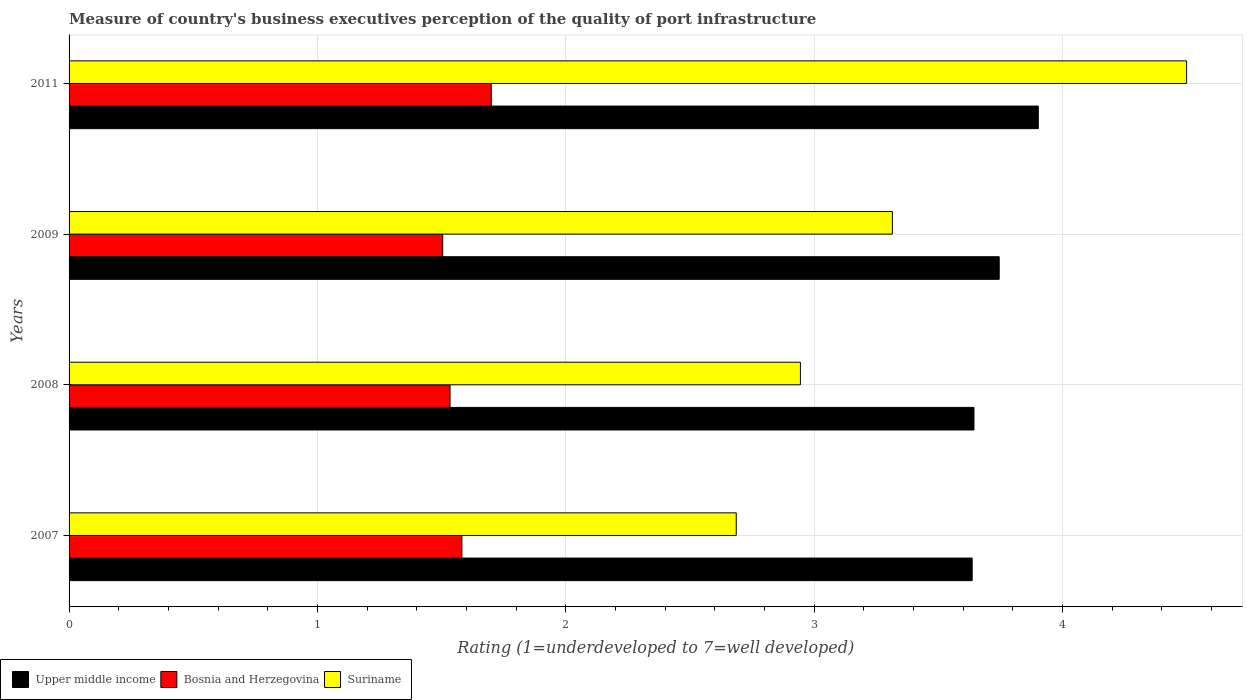What is the ratings of the quality of port infrastructure in Upper middle income in 2007?
Provide a succinct answer. 3.64. Across all years, what is the maximum ratings of the quality of port infrastructure in Upper middle income?
Provide a short and direct response. 3.9. Across all years, what is the minimum ratings of the quality of port infrastructure in Suriname?
Keep it short and to the point. 2.69. In which year was the ratings of the quality of port infrastructure in Upper middle income maximum?
Give a very brief answer. 2011. What is the total ratings of the quality of port infrastructure in Suriname in the graph?
Provide a succinct answer. 13.45. What is the difference between the ratings of the quality of port infrastructure in Suriname in 2007 and that in 2009?
Provide a succinct answer. -0.63. What is the difference between the ratings of the quality of port infrastructure in Bosnia and Herzegovina in 2008 and the ratings of the quality of port infrastructure in Upper middle income in 2007?
Keep it short and to the point. -2.1. What is the average ratings of the quality of port infrastructure in Bosnia and Herzegovina per year?
Offer a very short reply. 1.58. In the year 2007, what is the difference between the ratings of the quality of port infrastructure in Upper middle income and ratings of the quality of port infrastructure in Bosnia and Herzegovina?
Your answer should be compact. 2.05. In how many years, is the ratings of the quality of port infrastructure in Suriname greater than 1.8 ?
Ensure brevity in your answer.  4. What is the ratio of the ratings of the quality of port infrastructure in Bosnia and Herzegovina in 2007 to that in 2009?
Ensure brevity in your answer.  1.05. Is the ratings of the quality of port infrastructure in Upper middle income in 2009 less than that in 2011?
Provide a succinct answer. Yes. Is the difference between the ratings of the quality of port infrastructure in Upper middle income in 2009 and 2011 greater than the difference between the ratings of the quality of port infrastructure in Bosnia and Herzegovina in 2009 and 2011?
Make the answer very short. Yes. What is the difference between the highest and the second highest ratings of the quality of port infrastructure in Upper middle income?
Provide a short and direct response. 0.16. What is the difference between the highest and the lowest ratings of the quality of port infrastructure in Suriname?
Offer a very short reply. 1.81. In how many years, is the ratings of the quality of port infrastructure in Suriname greater than the average ratings of the quality of port infrastructure in Suriname taken over all years?
Offer a very short reply. 1. Is the sum of the ratings of the quality of port infrastructure in Upper middle income in 2008 and 2009 greater than the maximum ratings of the quality of port infrastructure in Bosnia and Herzegovina across all years?
Make the answer very short. Yes. What does the 1st bar from the top in 2009 represents?
Offer a very short reply. Suriname. What does the 1st bar from the bottom in 2009 represents?
Ensure brevity in your answer.  Upper middle income. How many bars are there?
Offer a very short reply. 12. How many years are there in the graph?
Provide a succinct answer. 4. What is the difference between two consecutive major ticks on the X-axis?
Provide a succinct answer. 1. Where does the legend appear in the graph?
Provide a short and direct response. Bottom left. How are the legend labels stacked?
Give a very brief answer. Horizontal. What is the title of the graph?
Offer a terse response. Measure of country's business executives perception of the quality of port infrastructure. What is the label or title of the X-axis?
Provide a succinct answer. Rating (1=underdeveloped to 7=well developed). What is the Rating (1=underdeveloped to 7=well developed) of Upper middle income in 2007?
Your answer should be very brief. 3.64. What is the Rating (1=underdeveloped to 7=well developed) of Bosnia and Herzegovina in 2007?
Provide a short and direct response. 1.58. What is the Rating (1=underdeveloped to 7=well developed) of Suriname in 2007?
Your answer should be compact. 2.69. What is the Rating (1=underdeveloped to 7=well developed) of Upper middle income in 2008?
Your answer should be compact. 3.64. What is the Rating (1=underdeveloped to 7=well developed) in Bosnia and Herzegovina in 2008?
Your answer should be very brief. 1.53. What is the Rating (1=underdeveloped to 7=well developed) of Suriname in 2008?
Your response must be concise. 2.94. What is the Rating (1=underdeveloped to 7=well developed) in Upper middle income in 2009?
Offer a very short reply. 3.75. What is the Rating (1=underdeveloped to 7=well developed) in Bosnia and Herzegovina in 2009?
Your response must be concise. 1.5. What is the Rating (1=underdeveloped to 7=well developed) of Suriname in 2009?
Offer a terse response. 3.32. What is the Rating (1=underdeveloped to 7=well developed) of Upper middle income in 2011?
Offer a terse response. 3.9. Across all years, what is the maximum Rating (1=underdeveloped to 7=well developed) in Upper middle income?
Your answer should be very brief. 3.9. Across all years, what is the minimum Rating (1=underdeveloped to 7=well developed) of Upper middle income?
Provide a succinct answer. 3.64. Across all years, what is the minimum Rating (1=underdeveloped to 7=well developed) in Bosnia and Herzegovina?
Offer a very short reply. 1.5. Across all years, what is the minimum Rating (1=underdeveloped to 7=well developed) of Suriname?
Keep it short and to the point. 2.69. What is the total Rating (1=underdeveloped to 7=well developed) of Upper middle income in the graph?
Ensure brevity in your answer.  14.93. What is the total Rating (1=underdeveloped to 7=well developed) of Bosnia and Herzegovina in the graph?
Make the answer very short. 6.32. What is the total Rating (1=underdeveloped to 7=well developed) of Suriname in the graph?
Your response must be concise. 13.45. What is the difference between the Rating (1=underdeveloped to 7=well developed) of Upper middle income in 2007 and that in 2008?
Offer a very short reply. -0.01. What is the difference between the Rating (1=underdeveloped to 7=well developed) in Bosnia and Herzegovina in 2007 and that in 2008?
Offer a very short reply. 0.05. What is the difference between the Rating (1=underdeveloped to 7=well developed) in Suriname in 2007 and that in 2008?
Provide a short and direct response. -0.26. What is the difference between the Rating (1=underdeveloped to 7=well developed) of Upper middle income in 2007 and that in 2009?
Your answer should be very brief. -0.11. What is the difference between the Rating (1=underdeveloped to 7=well developed) of Bosnia and Herzegovina in 2007 and that in 2009?
Your answer should be compact. 0.08. What is the difference between the Rating (1=underdeveloped to 7=well developed) in Suriname in 2007 and that in 2009?
Your answer should be very brief. -0.63. What is the difference between the Rating (1=underdeveloped to 7=well developed) in Upper middle income in 2007 and that in 2011?
Your answer should be compact. -0.27. What is the difference between the Rating (1=underdeveloped to 7=well developed) of Bosnia and Herzegovina in 2007 and that in 2011?
Give a very brief answer. -0.12. What is the difference between the Rating (1=underdeveloped to 7=well developed) in Suriname in 2007 and that in 2011?
Your answer should be compact. -1.81. What is the difference between the Rating (1=underdeveloped to 7=well developed) of Upper middle income in 2008 and that in 2009?
Your answer should be compact. -0.1. What is the difference between the Rating (1=underdeveloped to 7=well developed) in Bosnia and Herzegovina in 2008 and that in 2009?
Your response must be concise. 0.03. What is the difference between the Rating (1=underdeveloped to 7=well developed) of Suriname in 2008 and that in 2009?
Offer a terse response. -0.37. What is the difference between the Rating (1=underdeveloped to 7=well developed) in Upper middle income in 2008 and that in 2011?
Provide a short and direct response. -0.26. What is the difference between the Rating (1=underdeveloped to 7=well developed) of Bosnia and Herzegovina in 2008 and that in 2011?
Provide a succinct answer. -0.17. What is the difference between the Rating (1=underdeveloped to 7=well developed) in Suriname in 2008 and that in 2011?
Keep it short and to the point. -1.55. What is the difference between the Rating (1=underdeveloped to 7=well developed) of Upper middle income in 2009 and that in 2011?
Your answer should be very brief. -0.16. What is the difference between the Rating (1=underdeveloped to 7=well developed) of Bosnia and Herzegovina in 2009 and that in 2011?
Give a very brief answer. -0.2. What is the difference between the Rating (1=underdeveloped to 7=well developed) of Suriname in 2009 and that in 2011?
Offer a very short reply. -1.18. What is the difference between the Rating (1=underdeveloped to 7=well developed) in Upper middle income in 2007 and the Rating (1=underdeveloped to 7=well developed) in Bosnia and Herzegovina in 2008?
Your answer should be very brief. 2.1. What is the difference between the Rating (1=underdeveloped to 7=well developed) of Upper middle income in 2007 and the Rating (1=underdeveloped to 7=well developed) of Suriname in 2008?
Your response must be concise. 0.69. What is the difference between the Rating (1=underdeveloped to 7=well developed) in Bosnia and Herzegovina in 2007 and the Rating (1=underdeveloped to 7=well developed) in Suriname in 2008?
Make the answer very short. -1.36. What is the difference between the Rating (1=underdeveloped to 7=well developed) in Upper middle income in 2007 and the Rating (1=underdeveloped to 7=well developed) in Bosnia and Herzegovina in 2009?
Give a very brief answer. 2.13. What is the difference between the Rating (1=underdeveloped to 7=well developed) of Upper middle income in 2007 and the Rating (1=underdeveloped to 7=well developed) of Suriname in 2009?
Offer a terse response. 0.32. What is the difference between the Rating (1=underdeveloped to 7=well developed) in Bosnia and Herzegovina in 2007 and the Rating (1=underdeveloped to 7=well developed) in Suriname in 2009?
Your answer should be very brief. -1.73. What is the difference between the Rating (1=underdeveloped to 7=well developed) of Upper middle income in 2007 and the Rating (1=underdeveloped to 7=well developed) of Bosnia and Herzegovina in 2011?
Offer a very short reply. 1.94. What is the difference between the Rating (1=underdeveloped to 7=well developed) in Upper middle income in 2007 and the Rating (1=underdeveloped to 7=well developed) in Suriname in 2011?
Provide a succinct answer. -0.86. What is the difference between the Rating (1=underdeveloped to 7=well developed) of Bosnia and Herzegovina in 2007 and the Rating (1=underdeveloped to 7=well developed) of Suriname in 2011?
Your answer should be very brief. -2.92. What is the difference between the Rating (1=underdeveloped to 7=well developed) of Upper middle income in 2008 and the Rating (1=underdeveloped to 7=well developed) of Bosnia and Herzegovina in 2009?
Offer a very short reply. 2.14. What is the difference between the Rating (1=underdeveloped to 7=well developed) in Upper middle income in 2008 and the Rating (1=underdeveloped to 7=well developed) in Suriname in 2009?
Give a very brief answer. 0.33. What is the difference between the Rating (1=underdeveloped to 7=well developed) in Bosnia and Herzegovina in 2008 and the Rating (1=underdeveloped to 7=well developed) in Suriname in 2009?
Offer a very short reply. -1.78. What is the difference between the Rating (1=underdeveloped to 7=well developed) of Upper middle income in 2008 and the Rating (1=underdeveloped to 7=well developed) of Bosnia and Herzegovina in 2011?
Offer a terse response. 1.94. What is the difference between the Rating (1=underdeveloped to 7=well developed) in Upper middle income in 2008 and the Rating (1=underdeveloped to 7=well developed) in Suriname in 2011?
Keep it short and to the point. -0.86. What is the difference between the Rating (1=underdeveloped to 7=well developed) of Bosnia and Herzegovina in 2008 and the Rating (1=underdeveloped to 7=well developed) of Suriname in 2011?
Make the answer very short. -2.97. What is the difference between the Rating (1=underdeveloped to 7=well developed) of Upper middle income in 2009 and the Rating (1=underdeveloped to 7=well developed) of Bosnia and Herzegovina in 2011?
Ensure brevity in your answer.  2.05. What is the difference between the Rating (1=underdeveloped to 7=well developed) of Upper middle income in 2009 and the Rating (1=underdeveloped to 7=well developed) of Suriname in 2011?
Provide a succinct answer. -0.75. What is the difference between the Rating (1=underdeveloped to 7=well developed) of Bosnia and Herzegovina in 2009 and the Rating (1=underdeveloped to 7=well developed) of Suriname in 2011?
Provide a short and direct response. -3. What is the average Rating (1=underdeveloped to 7=well developed) in Upper middle income per year?
Keep it short and to the point. 3.73. What is the average Rating (1=underdeveloped to 7=well developed) of Bosnia and Herzegovina per year?
Your response must be concise. 1.58. What is the average Rating (1=underdeveloped to 7=well developed) in Suriname per year?
Your answer should be compact. 3.36. In the year 2007, what is the difference between the Rating (1=underdeveloped to 7=well developed) in Upper middle income and Rating (1=underdeveloped to 7=well developed) in Bosnia and Herzegovina?
Keep it short and to the point. 2.05. In the year 2007, what is the difference between the Rating (1=underdeveloped to 7=well developed) of Bosnia and Herzegovina and Rating (1=underdeveloped to 7=well developed) of Suriname?
Provide a short and direct response. -1.1. In the year 2008, what is the difference between the Rating (1=underdeveloped to 7=well developed) of Upper middle income and Rating (1=underdeveloped to 7=well developed) of Bosnia and Herzegovina?
Give a very brief answer. 2.11. In the year 2008, what is the difference between the Rating (1=underdeveloped to 7=well developed) in Upper middle income and Rating (1=underdeveloped to 7=well developed) in Suriname?
Provide a short and direct response. 0.7. In the year 2008, what is the difference between the Rating (1=underdeveloped to 7=well developed) of Bosnia and Herzegovina and Rating (1=underdeveloped to 7=well developed) of Suriname?
Make the answer very short. -1.41. In the year 2009, what is the difference between the Rating (1=underdeveloped to 7=well developed) in Upper middle income and Rating (1=underdeveloped to 7=well developed) in Bosnia and Herzegovina?
Your answer should be very brief. 2.24. In the year 2009, what is the difference between the Rating (1=underdeveloped to 7=well developed) in Upper middle income and Rating (1=underdeveloped to 7=well developed) in Suriname?
Your answer should be compact. 0.43. In the year 2009, what is the difference between the Rating (1=underdeveloped to 7=well developed) in Bosnia and Herzegovina and Rating (1=underdeveloped to 7=well developed) in Suriname?
Give a very brief answer. -1.81. In the year 2011, what is the difference between the Rating (1=underdeveloped to 7=well developed) of Upper middle income and Rating (1=underdeveloped to 7=well developed) of Bosnia and Herzegovina?
Provide a short and direct response. 2.2. In the year 2011, what is the difference between the Rating (1=underdeveloped to 7=well developed) in Upper middle income and Rating (1=underdeveloped to 7=well developed) in Suriname?
Ensure brevity in your answer.  -0.6. What is the ratio of the Rating (1=underdeveloped to 7=well developed) in Upper middle income in 2007 to that in 2008?
Make the answer very short. 1. What is the ratio of the Rating (1=underdeveloped to 7=well developed) in Bosnia and Herzegovina in 2007 to that in 2008?
Give a very brief answer. 1.03. What is the ratio of the Rating (1=underdeveloped to 7=well developed) of Suriname in 2007 to that in 2008?
Keep it short and to the point. 0.91. What is the ratio of the Rating (1=underdeveloped to 7=well developed) in Upper middle income in 2007 to that in 2009?
Make the answer very short. 0.97. What is the ratio of the Rating (1=underdeveloped to 7=well developed) in Bosnia and Herzegovina in 2007 to that in 2009?
Keep it short and to the point. 1.05. What is the ratio of the Rating (1=underdeveloped to 7=well developed) of Suriname in 2007 to that in 2009?
Provide a short and direct response. 0.81. What is the ratio of the Rating (1=underdeveloped to 7=well developed) in Upper middle income in 2007 to that in 2011?
Provide a short and direct response. 0.93. What is the ratio of the Rating (1=underdeveloped to 7=well developed) in Bosnia and Herzegovina in 2007 to that in 2011?
Offer a terse response. 0.93. What is the ratio of the Rating (1=underdeveloped to 7=well developed) in Suriname in 2007 to that in 2011?
Make the answer very short. 0.6. What is the ratio of the Rating (1=underdeveloped to 7=well developed) in Upper middle income in 2008 to that in 2009?
Offer a terse response. 0.97. What is the ratio of the Rating (1=underdeveloped to 7=well developed) of Bosnia and Herzegovina in 2008 to that in 2009?
Provide a succinct answer. 1.02. What is the ratio of the Rating (1=underdeveloped to 7=well developed) of Suriname in 2008 to that in 2009?
Ensure brevity in your answer.  0.89. What is the ratio of the Rating (1=underdeveloped to 7=well developed) in Upper middle income in 2008 to that in 2011?
Provide a short and direct response. 0.93. What is the ratio of the Rating (1=underdeveloped to 7=well developed) in Bosnia and Herzegovina in 2008 to that in 2011?
Your answer should be very brief. 0.9. What is the ratio of the Rating (1=underdeveloped to 7=well developed) of Suriname in 2008 to that in 2011?
Ensure brevity in your answer.  0.65. What is the ratio of the Rating (1=underdeveloped to 7=well developed) of Upper middle income in 2009 to that in 2011?
Give a very brief answer. 0.96. What is the ratio of the Rating (1=underdeveloped to 7=well developed) in Bosnia and Herzegovina in 2009 to that in 2011?
Offer a very short reply. 0.89. What is the ratio of the Rating (1=underdeveloped to 7=well developed) of Suriname in 2009 to that in 2011?
Offer a terse response. 0.74. What is the difference between the highest and the second highest Rating (1=underdeveloped to 7=well developed) in Upper middle income?
Your response must be concise. 0.16. What is the difference between the highest and the second highest Rating (1=underdeveloped to 7=well developed) of Bosnia and Herzegovina?
Ensure brevity in your answer.  0.12. What is the difference between the highest and the second highest Rating (1=underdeveloped to 7=well developed) of Suriname?
Provide a short and direct response. 1.18. What is the difference between the highest and the lowest Rating (1=underdeveloped to 7=well developed) of Upper middle income?
Your answer should be very brief. 0.27. What is the difference between the highest and the lowest Rating (1=underdeveloped to 7=well developed) in Bosnia and Herzegovina?
Provide a succinct answer. 0.2. What is the difference between the highest and the lowest Rating (1=underdeveloped to 7=well developed) in Suriname?
Your answer should be very brief. 1.81. 